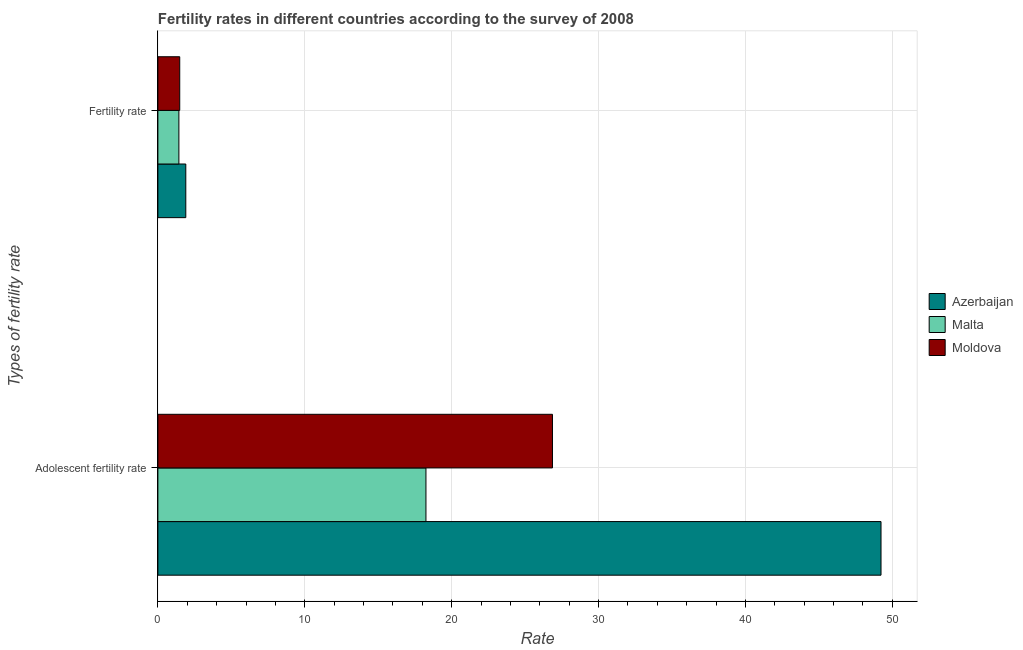Are the number of bars per tick equal to the number of legend labels?
Give a very brief answer. Yes. Are the number of bars on each tick of the Y-axis equal?
Provide a short and direct response. Yes. How many bars are there on the 2nd tick from the bottom?
Offer a very short reply. 3. What is the label of the 1st group of bars from the top?
Give a very brief answer. Fertility rate. What is the fertility rate in Moldova?
Offer a very short reply. 1.49. Across all countries, what is the maximum fertility rate?
Your answer should be compact. 1.9. Across all countries, what is the minimum adolescent fertility rate?
Give a very brief answer. 18.25. In which country was the fertility rate maximum?
Offer a terse response. Azerbaijan. In which country was the adolescent fertility rate minimum?
Keep it short and to the point. Malta. What is the total adolescent fertility rate in the graph?
Keep it short and to the point. 94.34. What is the difference between the adolescent fertility rate in Malta and that in Azerbaijan?
Give a very brief answer. -30.98. What is the difference between the fertility rate in Azerbaijan and the adolescent fertility rate in Malta?
Ensure brevity in your answer.  -16.35. What is the average fertility rate per country?
Give a very brief answer. 1.61. What is the difference between the adolescent fertility rate and fertility rate in Azerbaijan?
Your answer should be very brief. 47.33. In how many countries, is the fertility rate greater than 38 ?
Offer a very short reply. 0. What is the ratio of the adolescent fertility rate in Moldova to that in Malta?
Make the answer very short. 1.47. Is the fertility rate in Azerbaijan less than that in Malta?
Offer a terse response. No. What does the 1st bar from the top in Adolescent fertility rate represents?
Offer a very short reply. Moldova. What does the 1st bar from the bottom in Fertility rate represents?
Provide a short and direct response. Azerbaijan. How many bars are there?
Ensure brevity in your answer.  6. How many countries are there in the graph?
Provide a succinct answer. 3. What is the difference between two consecutive major ticks on the X-axis?
Give a very brief answer. 10. Are the values on the major ticks of X-axis written in scientific E-notation?
Make the answer very short. No. How many legend labels are there?
Give a very brief answer. 3. How are the legend labels stacked?
Offer a very short reply. Vertical. What is the title of the graph?
Make the answer very short. Fertility rates in different countries according to the survey of 2008. What is the label or title of the X-axis?
Give a very brief answer. Rate. What is the label or title of the Y-axis?
Ensure brevity in your answer.  Types of fertility rate. What is the Rate of Azerbaijan in Adolescent fertility rate?
Give a very brief answer. 49.23. What is the Rate in Malta in Adolescent fertility rate?
Keep it short and to the point. 18.25. What is the Rate of Moldova in Adolescent fertility rate?
Offer a very short reply. 26.86. What is the Rate in Azerbaijan in Fertility rate?
Provide a succinct answer. 1.9. What is the Rate in Malta in Fertility rate?
Keep it short and to the point. 1.43. What is the Rate in Moldova in Fertility rate?
Provide a succinct answer. 1.49. Across all Types of fertility rate, what is the maximum Rate of Azerbaijan?
Offer a terse response. 49.23. Across all Types of fertility rate, what is the maximum Rate in Malta?
Give a very brief answer. 18.25. Across all Types of fertility rate, what is the maximum Rate of Moldova?
Give a very brief answer. 26.86. Across all Types of fertility rate, what is the minimum Rate of Malta?
Make the answer very short. 1.43. Across all Types of fertility rate, what is the minimum Rate in Moldova?
Provide a succinct answer. 1.49. What is the total Rate of Azerbaijan in the graph?
Your answer should be compact. 51.13. What is the total Rate of Malta in the graph?
Offer a very short reply. 19.68. What is the total Rate in Moldova in the graph?
Your answer should be very brief. 28.35. What is the difference between the Rate in Azerbaijan in Adolescent fertility rate and that in Fertility rate?
Provide a short and direct response. 47.33. What is the difference between the Rate of Malta in Adolescent fertility rate and that in Fertility rate?
Ensure brevity in your answer.  16.82. What is the difference between the Rate in Moldova in Adolescent fertility rate and that in Fertility rate?
Keep it short and to the point. 25.37. What is the difference between the Rate in Azerbaijan in Adolescent fertility rate and the Rate in Malta in Fertility rate?
Ensure brevity in your answer.  47.8. What is the difference between the Rate in Azerbaijan in Adolescent fertility rate and the Rate in Moldova in Fertility rate?
Give a very brief answer. 47.74. What is the difference between the Rate in Malta in Adolescent fertility rate and the Rate in Moldova in Fertility rate?
Your answer should be compact. 16.76. What is the average Rate in Azerbaijan per Types of fertility rate?
Your answer should be compact. 25.56. What is the average Rate of Malta per Types of fertility rate?
Provide a short and direct response. 9.84. What is the average Rate in Moldova per Types of fertility rate?
Your response must be concise. 14.17. What is the difference between the Rate in Azerbaijan and Rate in Malta in Adolescent fertility rate?
Your answer should be compact. 30.98. What is the difference between the Rate of Azerbaijan and Rate of Moldova in Adolescent fertility rate?
Keep it short and to the point. 22.37. What is the difference between the Rate of Malta and Rate of Moldova in Adolescent fertility rate?
Offer a terse response. -8.61. What is the difference between the Rate of Azerbaijan and Rate of Malta in Fertility rate?
Provide a succinct answer. 0.47. What is the difference between the Rate in Azerbaijan and Rate in Moldova in Fertility rate?
Offer a very short reply. 0.41. What is the difference between the Rate in Malta and Rate in Moldova in Fertility rate?
Your answer should be compact. -0.06. What is the ratio of the Rate in Azerbaijan in Adolescent fertility rate to that in Fertility rate?
Offer a terse response. 25.91. What is the ratio of the Rate of Malta in Adolescent fertility rate to that in Fertility rate?
Keep it short and to the point. 12.76. What is the ratio of the Rate of Moldova in Adolescent fertility rate to that in Fertility rate?
Provide a short and direct response. 18.06. What is the difference between the highest and the second highest Rate of Azerbaijan?
Provide a short and direct response. 47.33. What is the difference between the highest and the second highest Rate of Malta?
Your answer should be very brief. 16.82. What is the difference between the highest and the second highest Rate in Moldova?
Keep it short and to the point. 25.37. What is the difference between the highest and the lowest Rate of Azerbaijan?
Ensure brevity in your answer.  47.33. What is the difference between the highest and the lowest Rate of Malta?
Offer a terse response. 16.82. What is the difference between the highest and the lowest Rate of Moldova?
Offer a terse response. 25.37. 